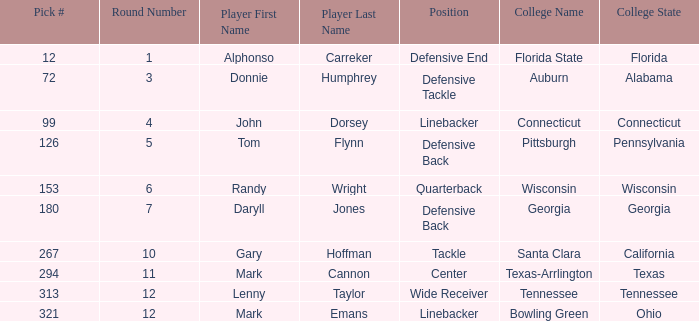What is Mark Cannon's College? Texas-Arrlington. 